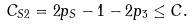<formula> <loc_0><loc_0><loc_500><loc_500>C _ { S 2 } = 2 p _ { S } - 1 - 2 p _ { 3 } \leq C .</formula> 